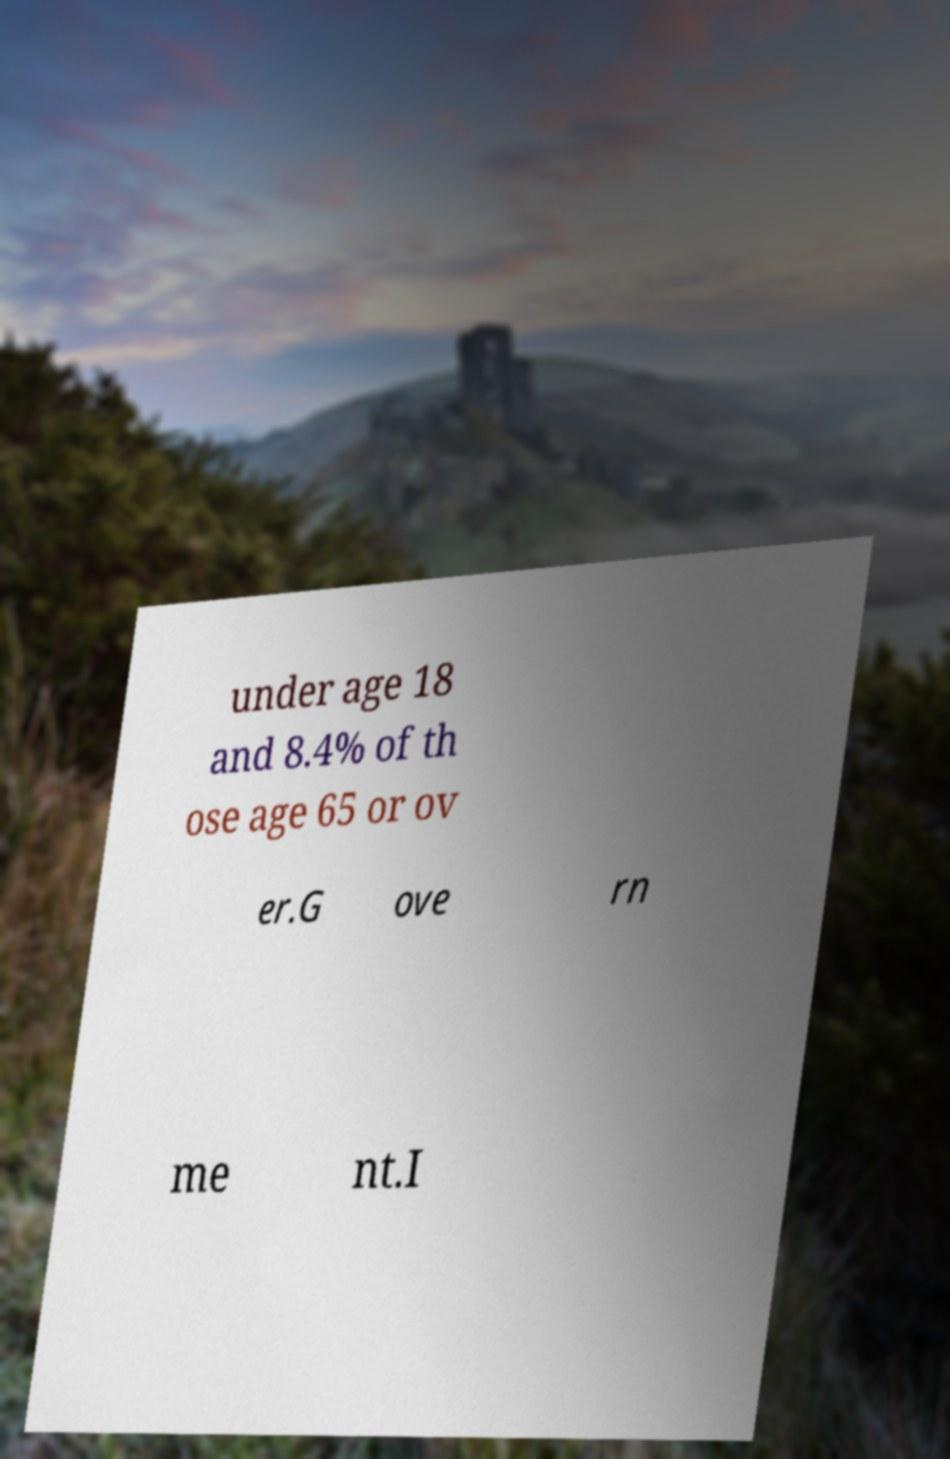For documentation purposes, I need the text within this image transcribed. Could you provide that? under age 18 and 8.4% of th ose age 65 or ov er.G ove rn me nt.I 